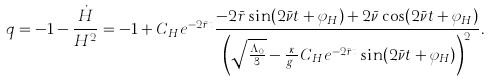Convert formula to latex. <formula><loc_0><loc_0><loc_500><loc_500>q = - 1 - \frac { \dot { H } } { H ^ { 2 } } = - 1 + C _ { H } e ^ { - 2 \bar { r } t } \frac { - 2 \bar { r } \sin ( 2 \bar { \nu } t + \varphi _ { H } ) + 2 \bar { \nu } \cos ( 2 \bar { \nu } t + \varphi _ { H } ) } { \left ( \sqrt { \frac { \Lambda _ { 0 } } { 3 } } - \frac { \kappa } { g _ { o } } C _ { H } e ^ { - 2 \bar { r } t } \sin ( 2 \bar { \nu } t + \varphi _ { H } ) \right ) ^ { 2 } } .</formula> 